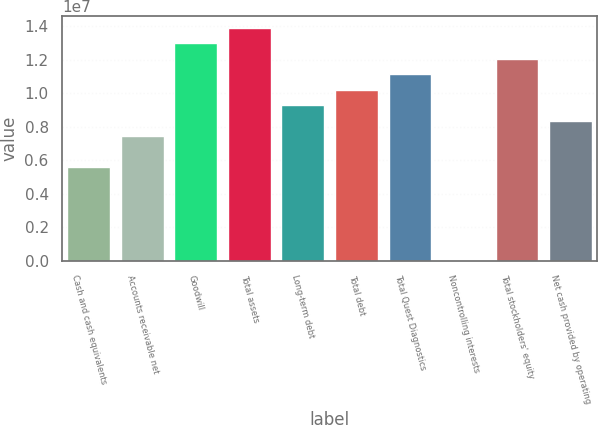<chart> <loc_0><loc_0><loc_500><loc_500><bar_chart><fcel>Cash and cash equivalents<fcel>Accounts receivable net<fcel>Goodwill<fcel>Total assets<fcel>Long-term debt<fcel>Total debt<fcel>Total Quest Diagnostics<fcel>Noncontrolling interests<fcel>Total stockholders' equity<fcel>Net cash provided by operating<nl><fcel>5.57939e+06<fcel>7.43163e+06<fcel>1.29883e+07<fcel>1.39145e+07<fcel>9.28386e+06<fcel>1.021e+07<fcel>1.11361e+07<fcel>22682<fcel>1.20622e+07<fcel>8.35774e+06<nl></chart> 